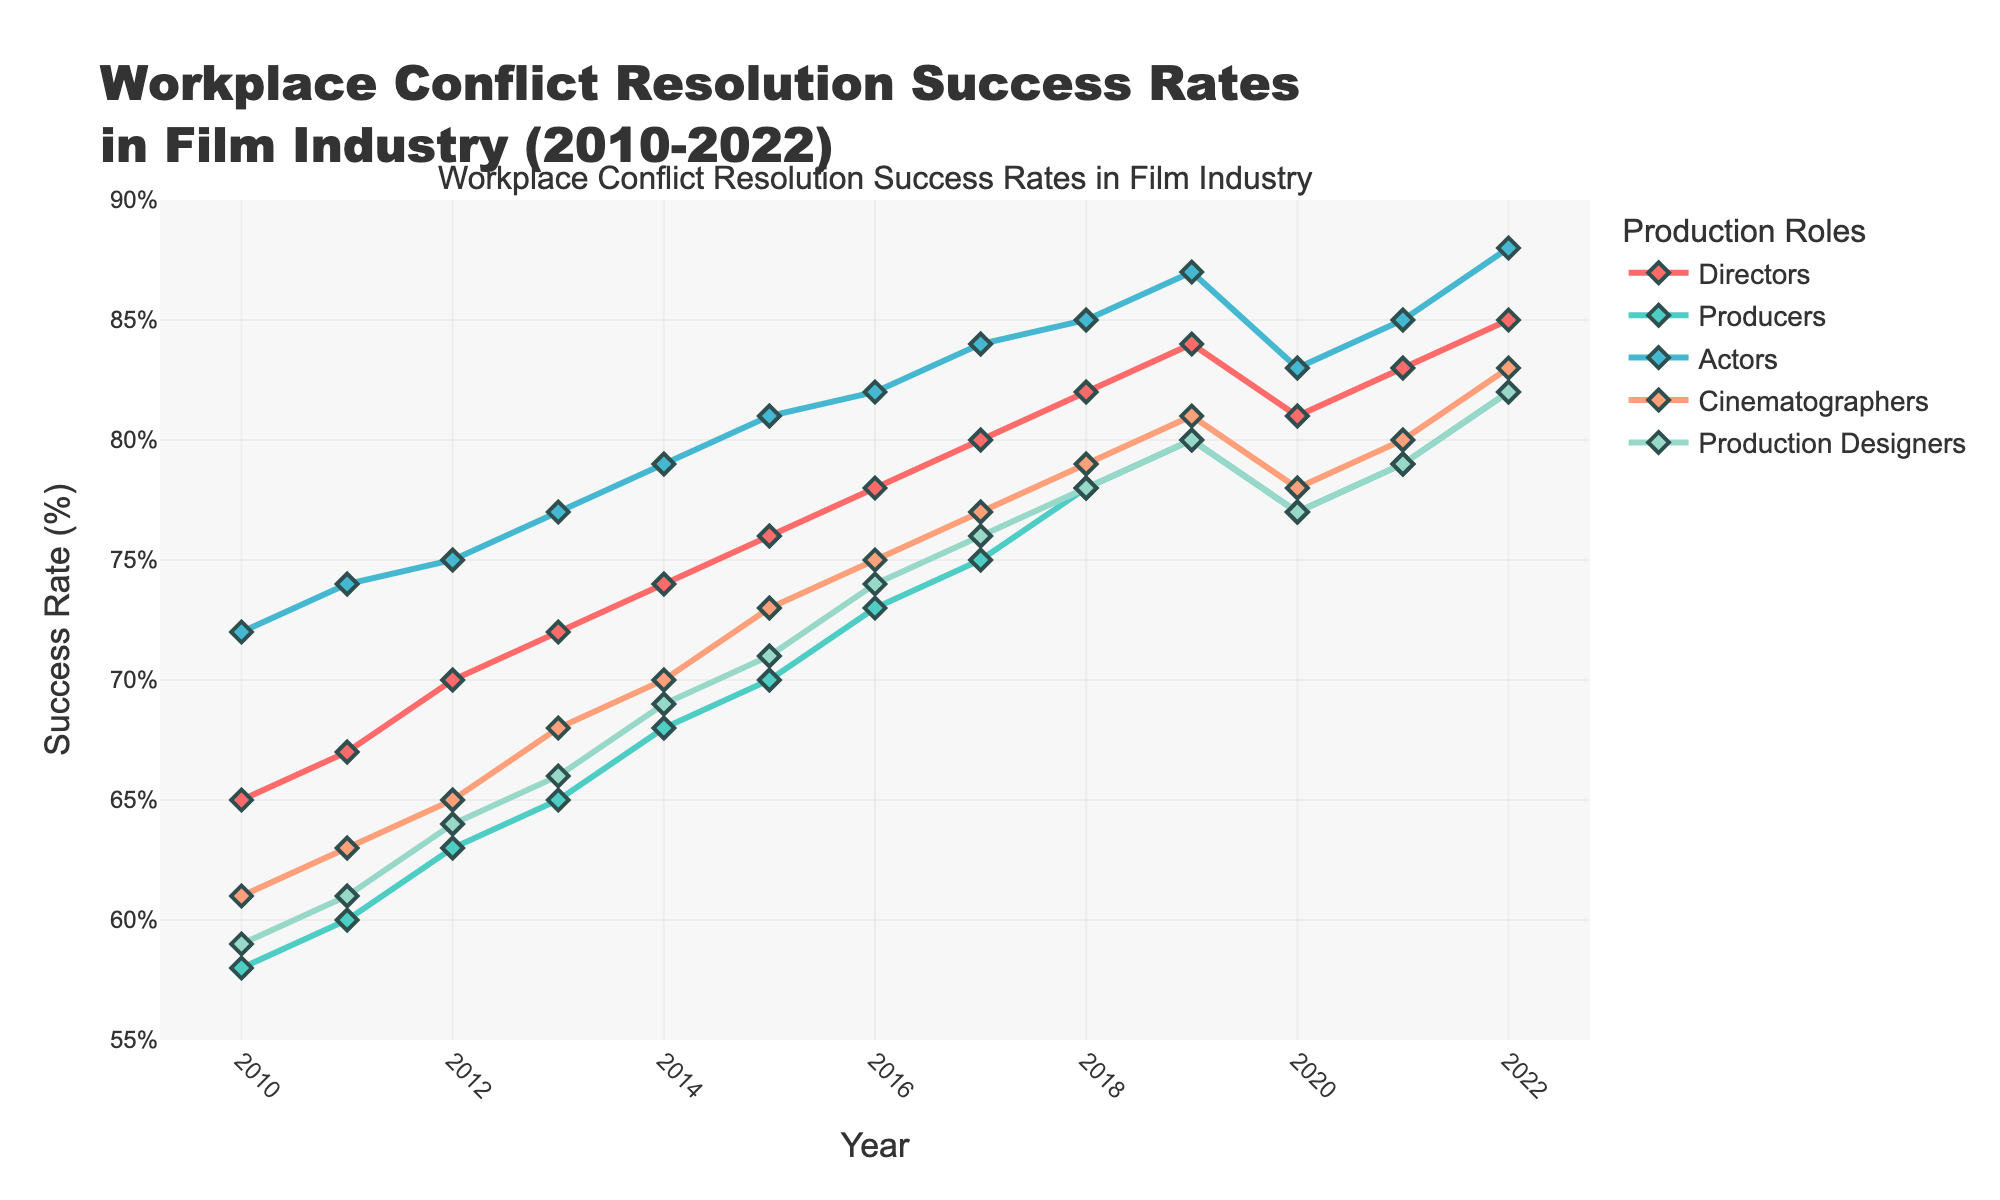What was the success rate for Producers in 2012? The line for Producers shows a success rate of 63% for the year 2012.
Answer: 63% Which role had the highest success rate in 2018? By comparing the heights of the lines for each role in 2018, the Actors had the highest success rate at 85%.
Answer: Actors How much did the success rate for Directors increase from 2010 to 2022? The success rate for Directors in 2010 was 65%. In 2022, it was 85%. The increase is 85% - 65% = 20%.
Answer: 20% Between which two consecutive years did the Cinematographers see the largest increase in success rates? Comparing year-over-year changes for Cinematographers, the largest increase was from 2016 to 2017, from 75% to 77%, an increase of 2%.
Answer: 2016 to 2017 What is the average success rate for Production Designers across the entire period? Sum the success rates for Production Designers from 2010 to 2022 and divide by the number of years (13). (59+61+64+66+69+71+74+76+78+80+77+79+82)/13 = 69.
Answer: 69% Did any role experience a decrease in success rate from 2019 to 2020? Comparing the values from 2019 to 2020 for all roles, the Directors and Cinematographers both show a decrease. Directors went from 84% to 81%, and Cinematographers from 81% to 78%.
Answer: Yes Which role had the most stable success rate trend over the years, and how can you tell? By examining the lines, Producers had a more consistent and smooth upward trend, indicating stability compared to the other roles with more fluctuations.
Answer: Producers What is the difference in success rates between Actors and Cinematographers in 2021? In 2021, Actors had a success rate of 85% and Cinematographers had 80%. The difference is 85% - 80% = 5%.
Answer: 5% If you were to consider a role with the most significant improvement in success rates from 2010 to 2022, which would it be and by how much? Actors had the highest improvement, from 72% in 2010 to 88% in 2022. The improvement is 88% - 72% = 16%.
Answer: 16% In which year did the Production Designers achieve a success rate above 80% for the first time? The first year Production Designers' success rate rose above 80% was in 2022, reaching 82%.
Answer: 2022 